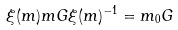<formula> <loc_0><loc_0><loc_500><loc_500>\xi ( m ) m { G } \xi ( m ) ^ { - 1 } = m _ { 0 } { G }</formula> 